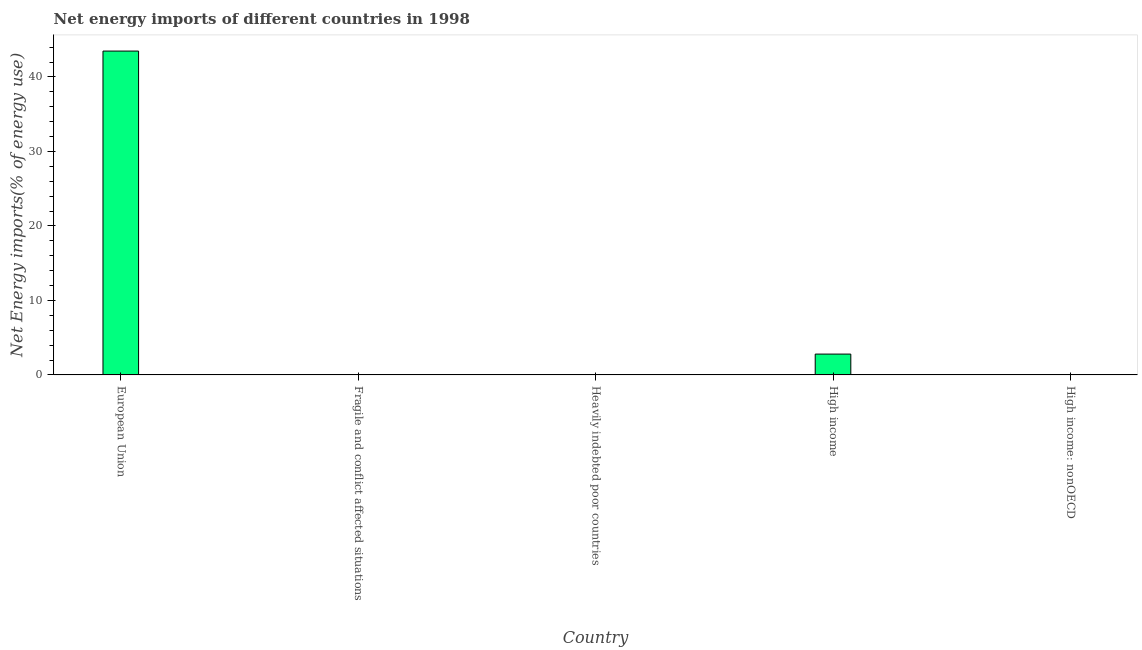Does the graph contain any zero values?
Ensure brevity in your answer.  Yes. Does the graph contain grids?
Make the answer very short. No. What is the title of the graph?
Provide a short and direct response. Net energy imports of different countries in 1998. What is the label or title of the Y-axis?
Offer a terse response. Net Energy imports(% of energy use). Across all countries, what is the maximum energy imports?
Keep it short and to the point. 43.47. What is the sum of the energy imports?
Make the answer very short. 46.26. What is the average energy imports per country?
Your answer should be compact. 9.25. In how many countries, is the energy imports greater than 14 %?
Keep it short and to the point. 1. Is the difference between the energy imports in European Union and High income greater than the difference between any two countries?
Offer a terse response. No. What is the difference between the highest and the lowest energy imports?
Ensure brevity in your answer.  43.47. In how many countries, is the energy imports greater than the average energy imports taken over all countries?
Provide a succinct answer. 1. Are all the bars in the graph horizontal?
Provide a short and direct response. No. What is the Net Energy imports(% of energy use) of European Union?
Make the answer very short. 43.47. What is the Net Energy imports(% of energy use) of Fragile and conflict affected situations?
Give a very brief answer. 0. What is the Net Energy imports(% of energy use) in High income?
Provide a succinct answer. 2.8. What is the Net Energy imports(% of energy use) of High income: nonOECD?
Your response must be concise. 0. What is the difference between the Net Energy imports(% of energy use) in European Union and High income?
Provide a short and direct response. 40.67. What is the ratio of the Net Energy imports(% of energy use) in European Union to that in High income?
Ensure brevity in your answer.  15.55. 